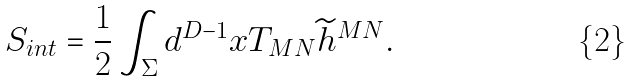Convert formula to latex. <formula><loc_0><loc_0><loc_500><loc_500>S _ { i n t } = { \frac { 1 } { 2 } } \int _ { \Sigma } d ^ { D - 1 } x T _ { M N } { \widetilde { h } } ^ { M N } .</formula> 